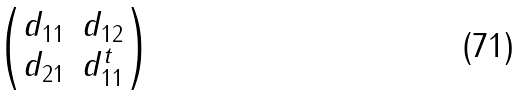<formula> <loc_0><loc_0><loc_500><loc_500>\begin{pmatrix} d _ { 1 1 } & d _ { 1 2 } \\ d _ { 2 1 } & d _ { 1 1 } ^ { t } \end{pmatrix}</formula> 